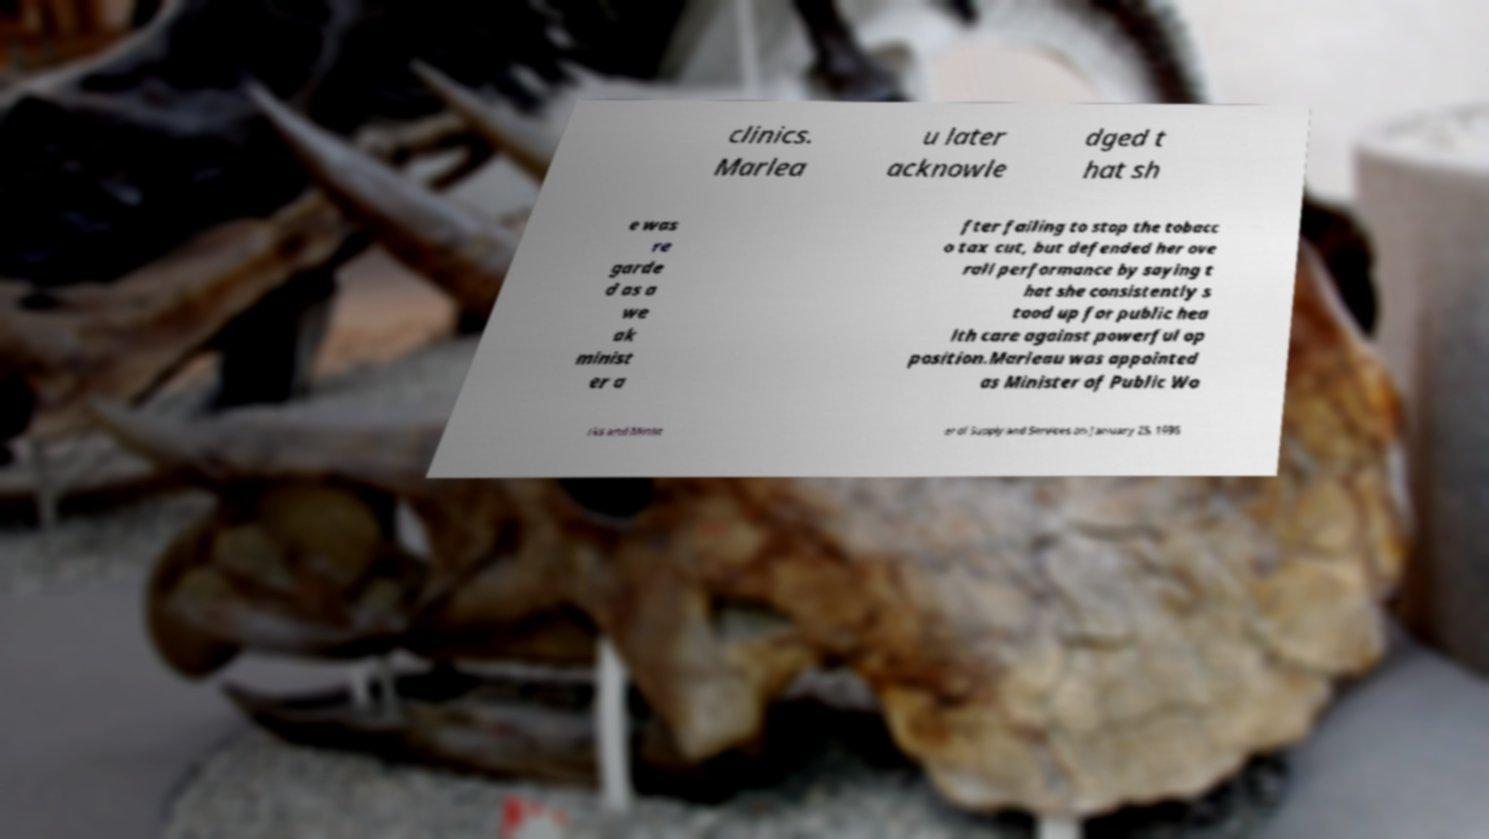Please read and relay the text visible in this image. What does it say? clinics. Marlea u later acknowle dged t hat sh e was re garde d as a we ak minist er a fter failing to stop the tobacc o tax cut, but defended her ove rall performance by saying t hat she consistently s tood up for public hea lth care against powerful op position.Marleau was appointed as Minister of Public Wo rks and Minist er of Supply and Services on January 25, 1996 